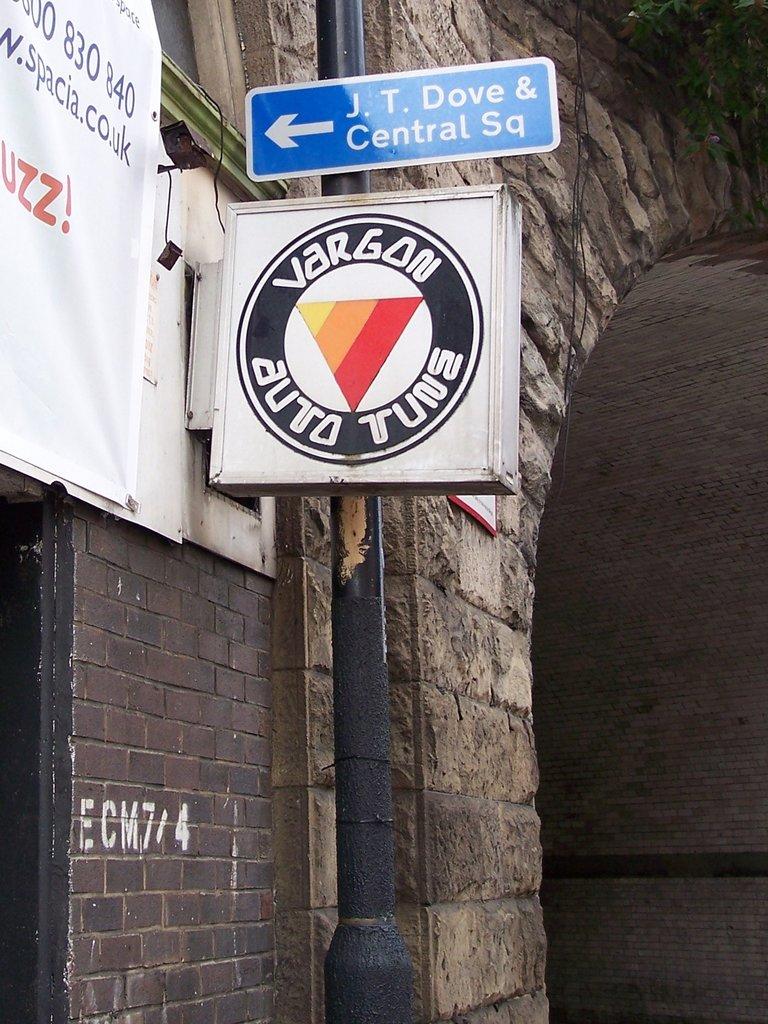What is the blue sign showing directions to?
Keep it short and to the point. J.t. dove & central sq. 